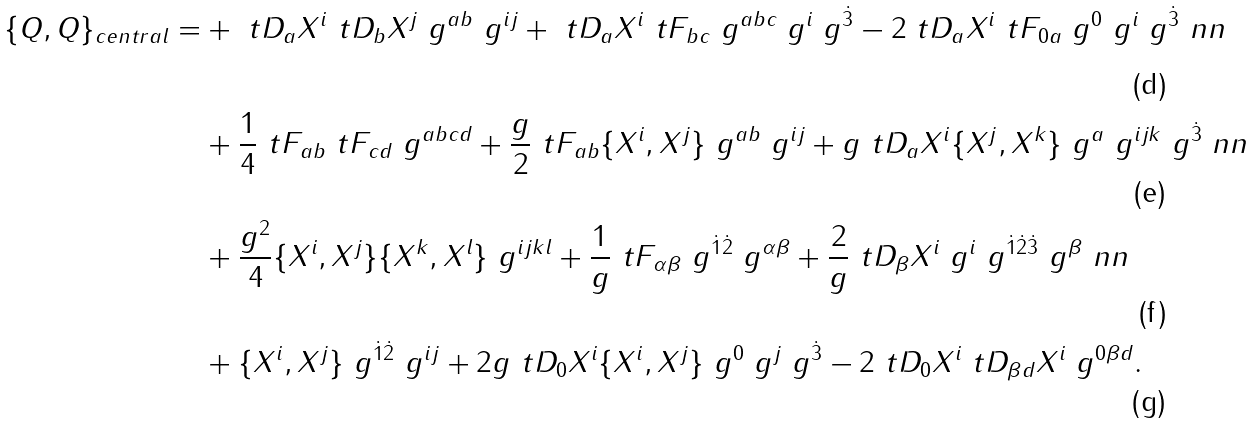Convert formula to latex. <formula><loc_0><loc_0><loc_500><loc_500>\{ Q , Q \} _ { c e n t r a l } = & + \ t D _ { a } X ^ { i } \ t D _ { b } X ^ { j } \ g ^ { a b } \ g ^ { i j } + \ t D _ { a } X ^ { i } \ t F _ { b c } \ g ^ { a b c } \ g ^ { i } \ g ^ { \dot { 3 } } - 2 \ t D _ { a } X ^ { i } \ t F _ { 0 a } \ g ^ { 0 } \ g ^ { i } \ g ^ { \dot { 3 } } \ n n \\ & + \frac { 1 } { 4 } \ t F _ { a b } \ t F _ { c d } \ g ^ { a b c d } + \frac { g } { 2 } \ t F _ { a b } \{ X ^ { i } , X ^ { j } \} \ g ^ { a b } \ g ^ { i j } + g \ t D _ { a } X ^ { i } \{ X ^ { j } , X ^ { k } \} \ g ^ { a } \ g ^ { i j k } \ g ^ { \dot { 3 } } \ n n \\ & + \frac { g ^ { 2 } } { 4 } \{ X ^ { i } , X ^ { j } \} \{ X ^ { k } , X ^ { l } \} \ g ^ { i j k l } + \frac { 1 } { g } \ t F _ { \alpha \beta } \ g ^ { \dot { 1 } \dot { 2 } } \ g ^ { \alpha \beta } + \frac { 2 } { g } \ t D _ { \beta } X ^ { i } \ g ^ { i } \ g ^ { \dot { 1 } \dot { 2 } \dot { 3 } } \ g ^ { \beta } \ n n \\ & + \{ X ^ { i } , X ^ { j } \} \ g ^ { \dot { 1 } \dot { 2 } } \ g ^ { i j } + 2 g \ t D _ { 0 } X ^ { i } \{ X ^ { i } , X ^ { j } \} \ g ^ { 0 } \ g ^ { j } \ g ^ { \dot { 3 } } - 2 \ t D _ { 0 } X ^ { i } \ t D _ { \beta d } X ^ { i } \ g ^ { 0 \beta d } .</formula> 